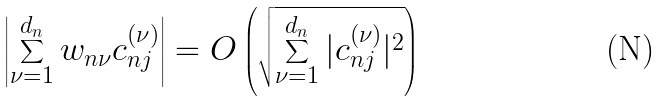<formula> <loc_0><loc_0><loc_500><loc_500>\left | \sum _ { \nu = 1 } ^ { d _ { n } } w _ { n \nu } c _ { n j } ^ { ( \nu ) } \right | = O \left ( \sqrt { \sum _ { \nu = 1 } ^ { d _ { n } } | c _ { n j } ^ { ( \nu ) } | ^ { 2 } } \right )</formula> 